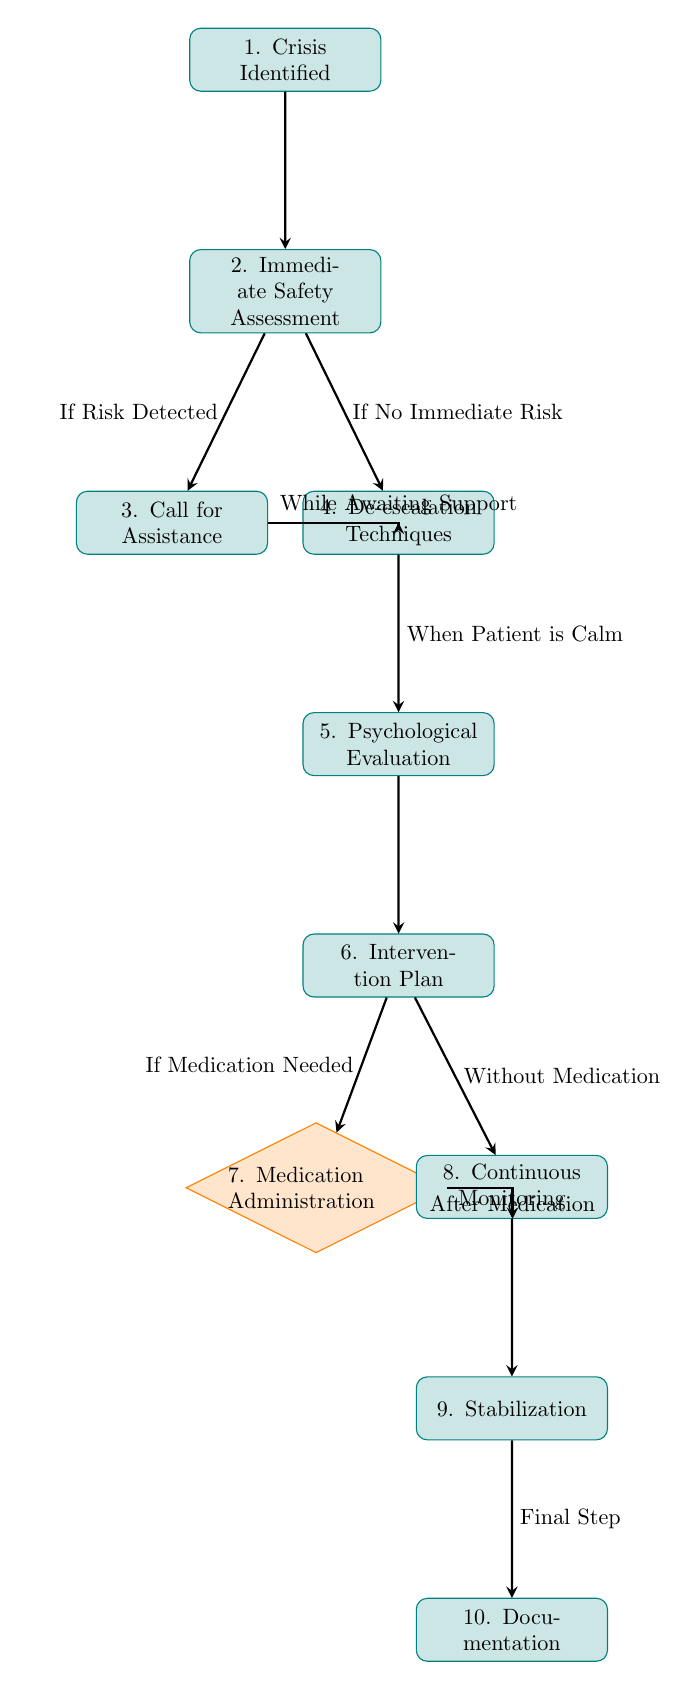What is the first step in the crisis intervention process? The diagram starts with the first node labeled "Crisis Identified." This indicates the initiation of the intervention process.
Answer: Crisis Identified How many decision points are in the diagram? There is only one decision point in the diagram, which is labeled "Medication Administration." This node represents a choice in the intervention plan.
Answer: 1 What action is taken if immediate risk is detected? If immediate risk is detected, the diagram indicates to "Call for Assistance," which is a key action to ensure safety.
Answer: Call for Assistance What happens after the psychological evaluation? Following the psychological evaluation, the next step in the process is to create an "Intervention Plan," where specific strategies for the patient's care are outlined.
Answer: Intervention Plan Describe the final step of the flowchart. The last action in the flowchart is "Documentation," which serves as a record of the entire intervention process, ensuring that all steps and decisions are noted for future reference.
Answer: Documentation What is done while awaiting support after calling for assistance? The diagram indicates that "De-escalation Techniques" should be employed while support is on the way, providing a means to manage the crisis until additional help arrives.
Answer: De-escalation Techniques What happens if no immediate risk is detected? If no immediate risk is detected, the flowchart directs to use "De-escalation Techniques" to calm the patient and stabilize the situation without immediate dangers.
Answer: De-escalation Techniques How does the diagram connect medication administration and continuous monitoring? The diagram shows that after "Medication Administration," the next step is "Continuous Monitoring," indicating a follow-up action to observe the patient’s response post-medication.
Answer: Continuous Monitoring What is the relationship between the 'Intervention Plan' and 'Medication Administration'? The diagram signifies that 'Medication Administration' occurs only if the plan indicates that medication is needed, illustrating a conditional relationship.
Answer: If Medication Needed 